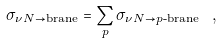Convert formula to latex. <formula><loc_0><loc_0><loc_500><loc_500>\sigma _ { \nu N \to \text {brane} } = \sum _ { p } \sigma _ { \nu N \to p \text {-brane} } \ ,</formula> 